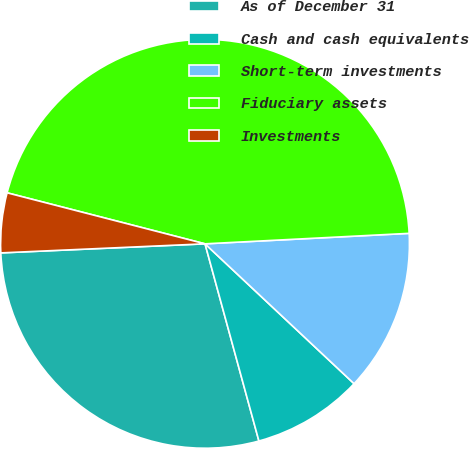Convert chart to OTSL. <chart><loc_0><loc_0><loc_500><loc_500><pie_chart><fcel>As of December 31<fcel>Cash and cash equivalents<fcel>Short-term investments<fcel>Fiduciary assets<fcel>Investments<nl><fcel>28.54%<fcel>8.76%<fcel>12.81%<fcel>45.17%<fcel>4.72%<nl></chart> 